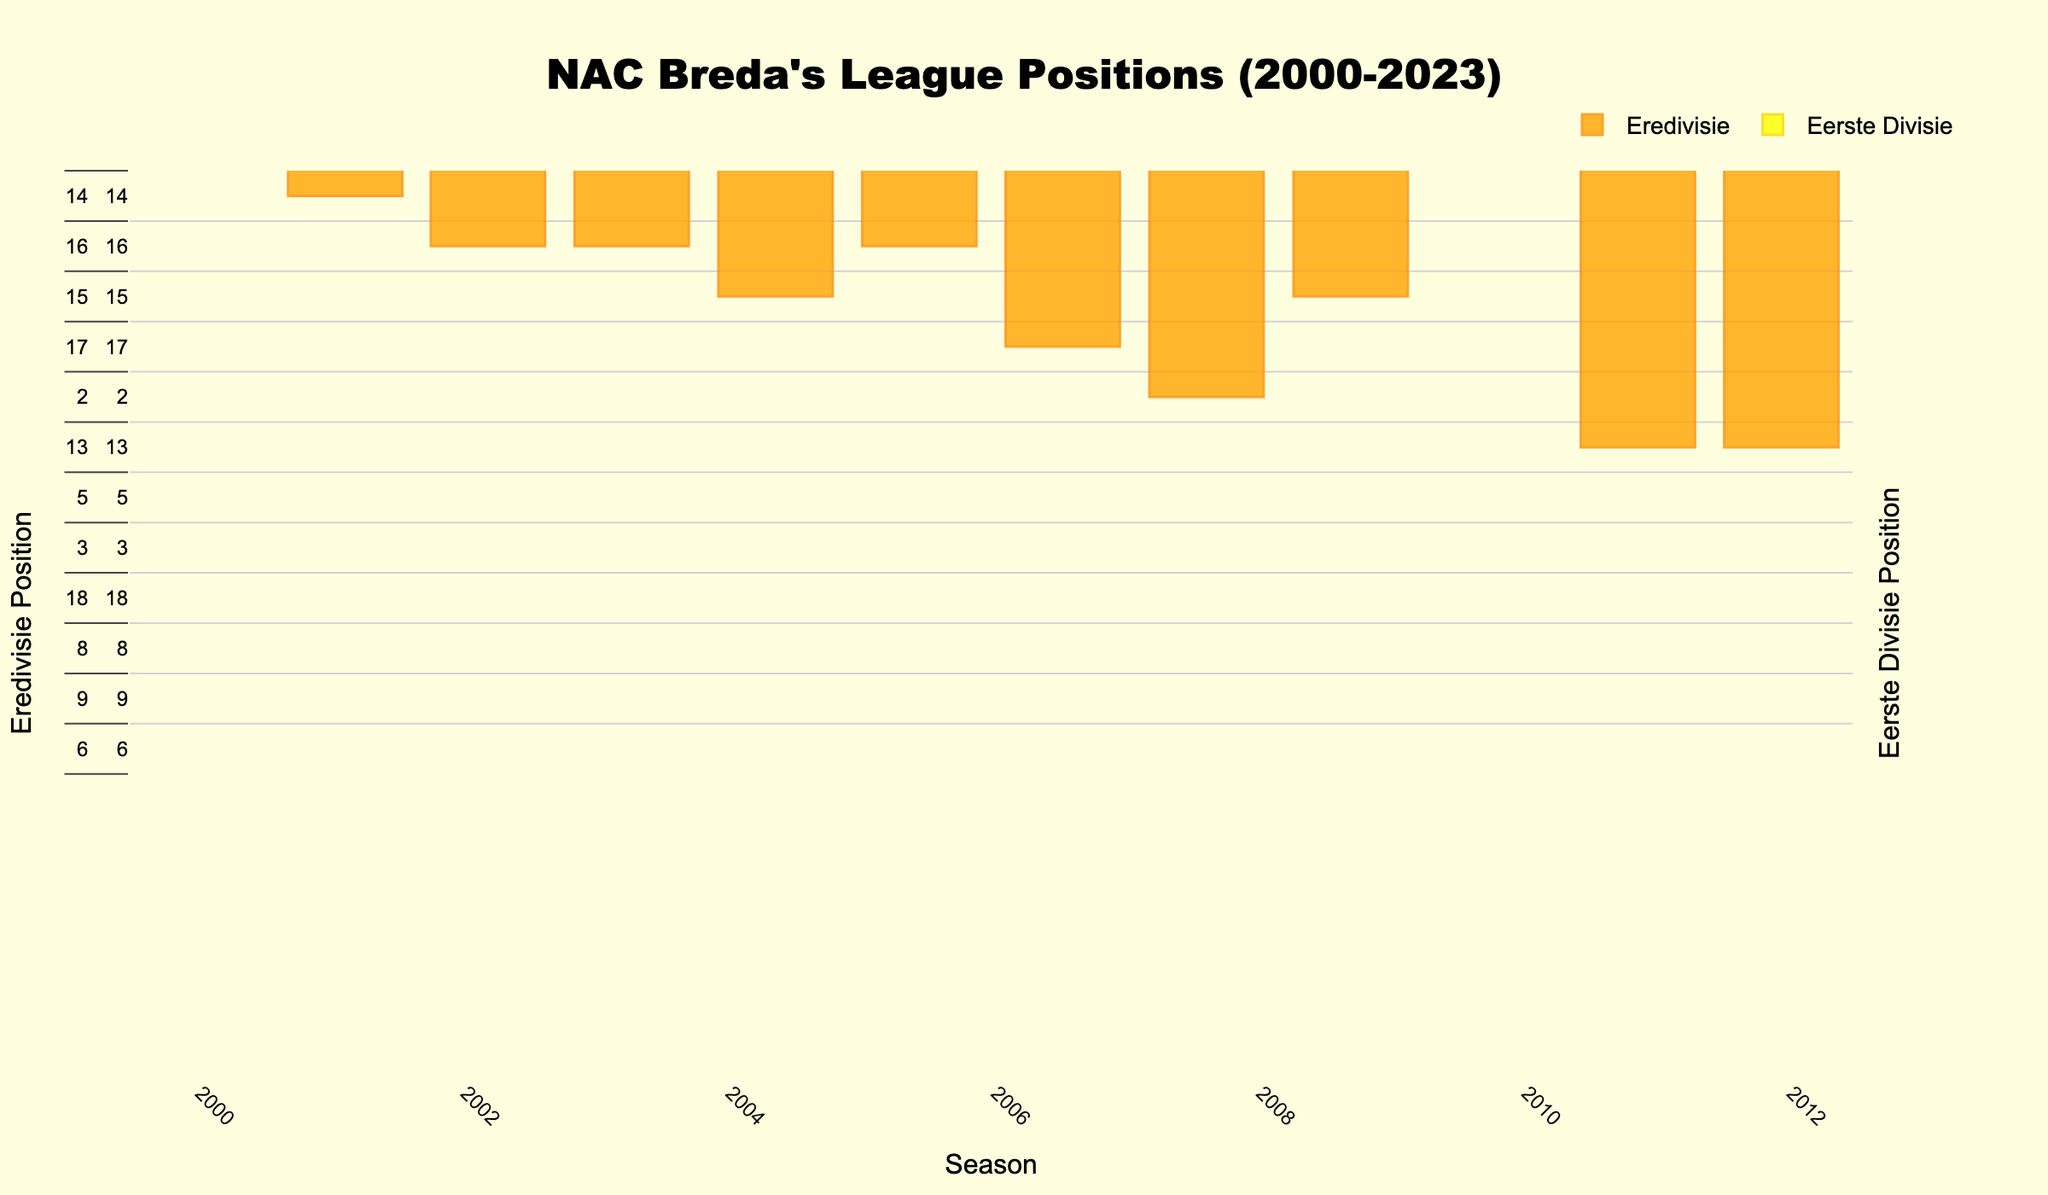What is the average position NAC Breda held in the Eredivisie during the seasons shown? To calculate this, sum the positions held in the Eredivisie and then divide by the number of Eredivisie seasons. The positions are 10, 14, 16, 16, 15, 16, 17, 15, 10, 13, 13, 13, 15, 16, 17, 18. Adding these gives 224, and there are 16 seasons in the Eredivisie, so the average position is 224 / 16 = 14.
Answer: 14 How many seasons did NAC Breda finish in the top 10 positions in any league? Identify the seasons where the position is less than or equal to 10. For Eredivisie, this occurred in the 2000-01 and 2009-10 seasons. For Eerste Divisie, this occurred in the 2007-08, 2016-17, 2017-18, 2019-20, and 2022-23 seasons. The total is 2 (Eredivisie) + 5 (Eerste Divisie) = 7 seasons.
Answer: 7 In which season did NAC Breda achieve their best position, and what was the position? Look for the lowest position number in both leagues. The best position was 2nd place in the Eerste Divisie in the 2007-08 season.
Answer: 2007-08, 2nd How many times were they relegated from Eredivisie based on their positions? Relegation in Eredivisie generally happens for teams finishing in the bottom three positions (16th, 17th, 18th). They finished in these positions in 2002-03, 2003-04, 2005-06, 2006-07, 2014-15, 2015-16, and 2018-19. Hence, they were relegated 7 times.
Answer: 7 Compare the highest position NAC Breda achieved in the Eredivisie versus the Eerste Divisie. The highest position in Eredivisie was 10th (2000-01, 2009-10) and in Eerste Divisie was 2nd (2007-08). 2nd in Eerste Divisie is higher than 10th in Eredivisie.
Answer: Eerste Divisie During which seasons did NAC Breda remain in the same position consecutively in the Eredivisie? Check for consecutive seasons with the same Eredivisie position. It occurred in the 2002-03 and 2003-04 seasons with a position of 16th, and in 2011-12 and 2012-13 seasons with a position of 13th.
Answer: 2002-03 to 2003-04, 2011-12 to 2012-13 Which season had the largest improvement in position from the previous season in the Eerste Divisie? Compare the position improvements between consecutive seasons in Eerste Divisie. The largest improvement is from 17th in 2006-07 (Eredivisie) to 2nd in 2007-08 (Eerste Divisie), which is an improvement of 15 positions.
Answer: 2007-08 What is the median position for NAC Breda in the Eerste Divisie across all the seasons shown? List the positions and find the median. The positions are 2, 5, 3, 5, 8, 9, 6. The median is the middle value when the data is ordered: 2, 3, 5, 5, 6, 8, 9. The median is the fourth value, which is 5.
Answer: 5 Identify the color used for Eredivisie vs Eerste Divisie in the plot. Observing the visual attributes, Eredivisie bars are colored orange and Eerste Divisie bars are colored yellow.
Answer: Eredivisie: orange, Eerste Divisie: yellow Which position has NAC Breda never finished at in the Eredivisie based on the data? Based on the data, they have never finished in the 1st, 2nd, 3rd, 4th, 5th, 6th, 7th, 8th, 9th, 11th, and 12th positions in Eredivisie.
Answer: 1st to 9th, 11th, 12th 